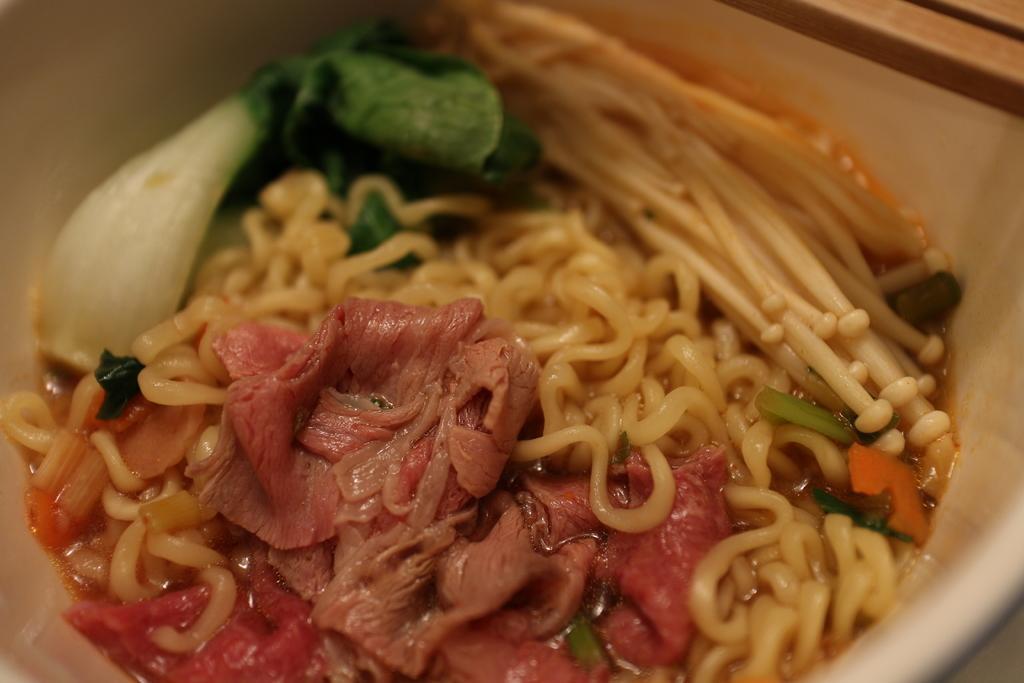How would you summarize this image in a sentence or two? In this picture we can see a table. On the table we can see a bowl which contains food. 